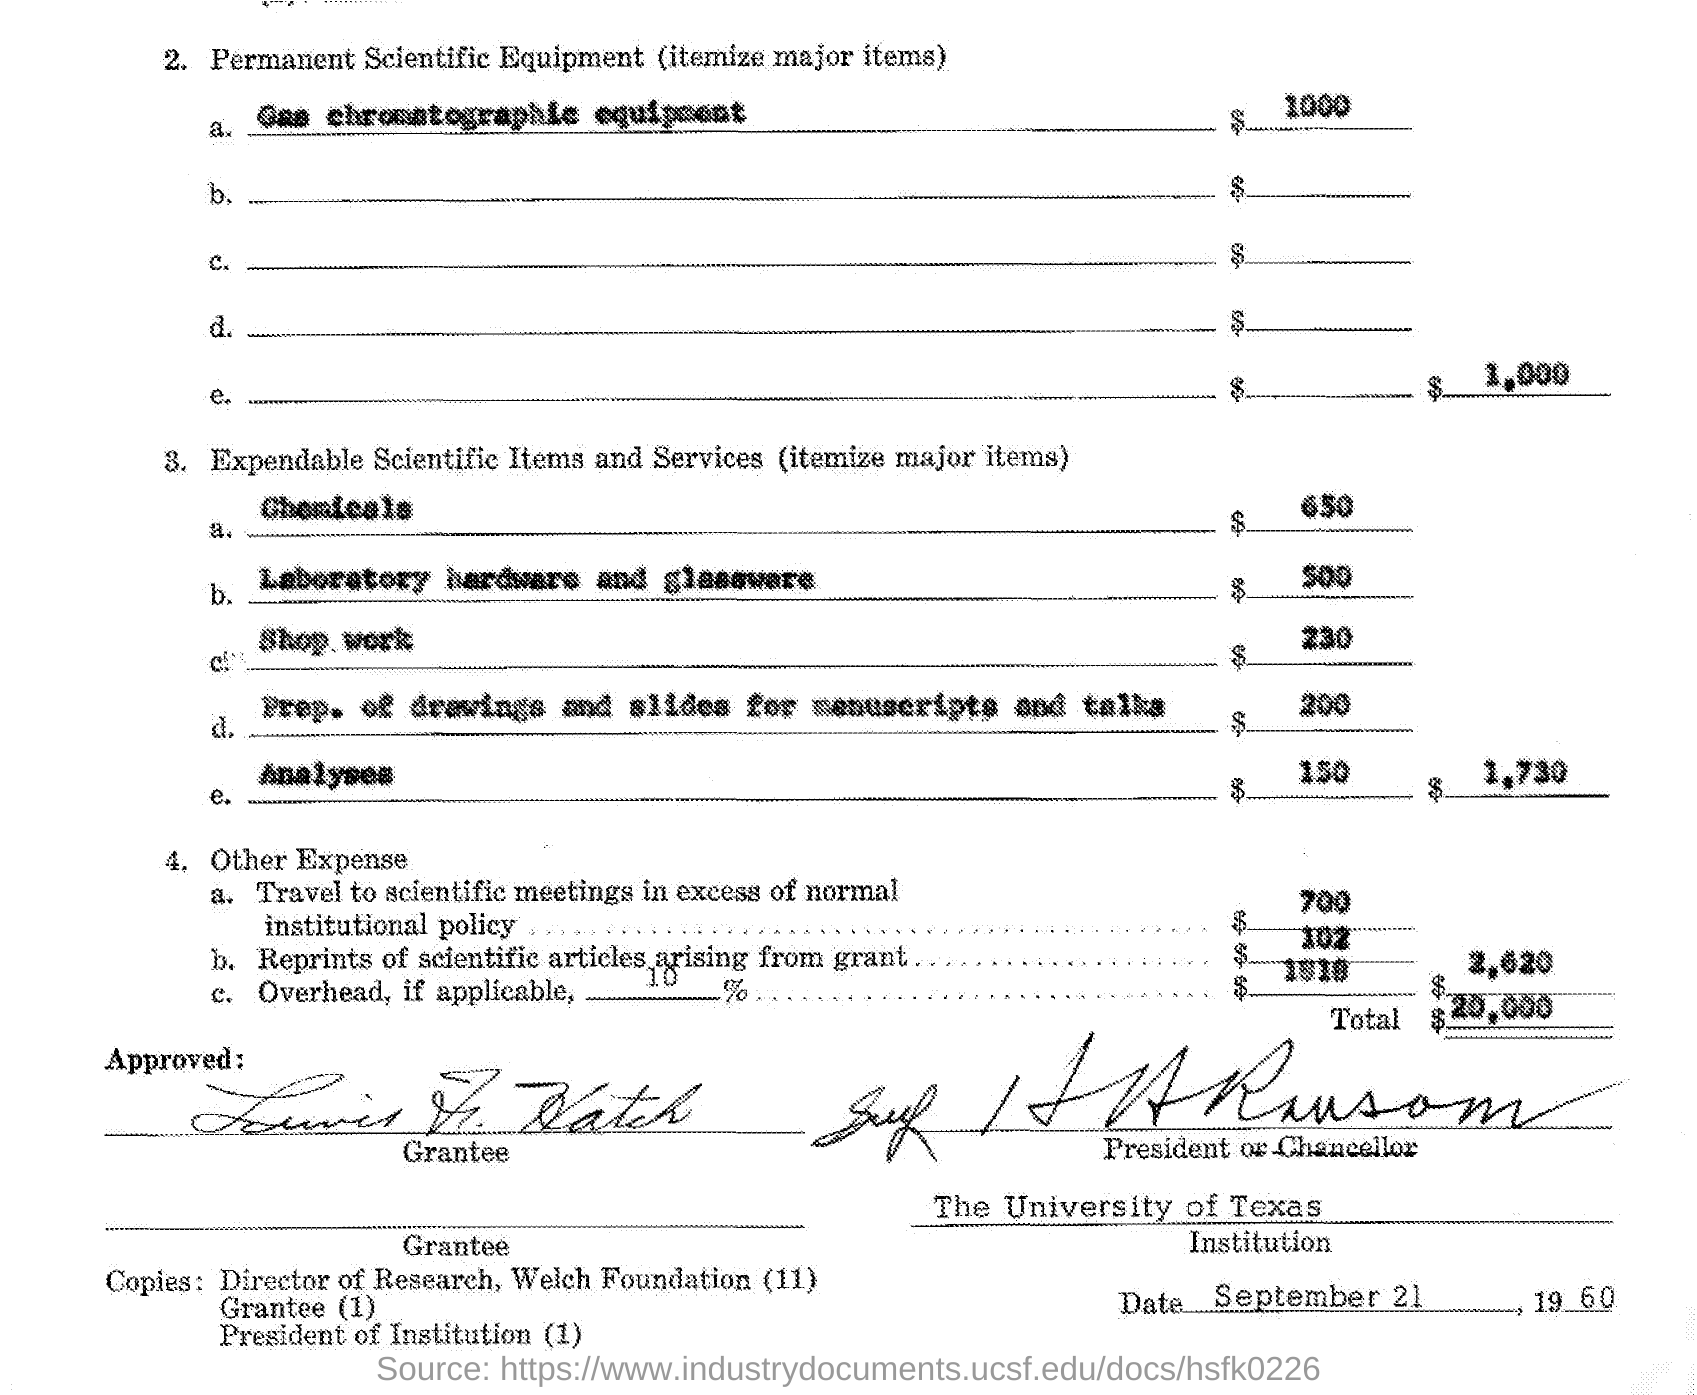What is the cost of gas chromatographic equipment ?
Your response must be concise. $ 1000. What is the cost of chemicals ?
Keep it short and to the point. $650. What is the cost for laboratory hardware and glassware ?
Your response must be concise. $ 500. What is the cost of shop work ?
Make the answer very short. $230. What is the total cost of expandable scientific items and services ?
Your answer should be compact. $1730. What is the cost of reprints of scientific articles arising from grant ?
Keep it short and to the point. $102. What is the value of total expenses mentioned in the given page ?
Offer a very short reply. $ 20,000. What is the date mentioned in the given page ?
Offer a very short reply. September 21 , 1960. 